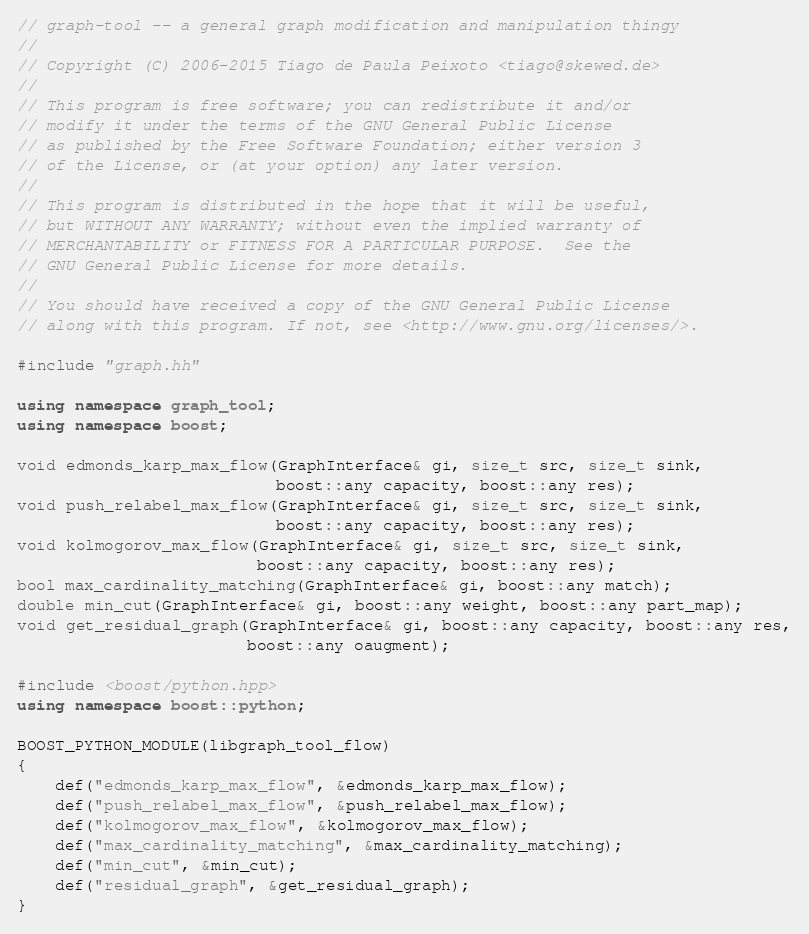<code> <loc_0><loc_0><loc_500><loc_500><_C++_>// graph-tool -- a general graph modification and manipulation thingy
//
// Copyright (C) 2006-2015 Tiago de Paula Peixoto <tiago@skewed.de>
//
// This program is free software; you can redistribute it and/or
// modify it under the terms of the GNU General Public License
// as published by the Free Software Foundation; either version 3
// of the License, or (at your option) any later version.
//
// This program is distributed in the hope that it will be useful,
// but WITHOUT ANY WARRANTY; without even the implied warranty of
// MERCHANTABILITY or FITNESS FOR A PARTICULAR PURPOSE.  See the
// GNU General Public License for more details.
//
// You should have received a copy of the GNU General Public License
// along with this program. If not, see <http://www.gnu.org/licenses/>.

#include "graph.hh"

using namespace graph_tool;
using namespace boost;

void edmonds_karp_max_flow(GraphInterface& gi, size_t src, size_t sink,
                           boost::any capacity, boost::any res);
void push_relabel_max_flow(GraphInterface& gi, size_t src, size_t sink,
                           boost::any capacity, boost::any res);
void kolmogorov_max_flow(GraphInterface& gi, size_t src, size_t sink,
                         boost::any capacity, boost::any res);
bool max_cardinality_matching(GraphInterface& gi, boost::any match);
double min_cut(GraphInterface& gi, boost::any weight, boost::any part_map);
void get_residual_graph(GraphInterface& gi, boost::any capacity, boost::any res,
                        boost::any oaugment);

#include <boost/python.hpp>
using namespace boost::python;

BOOST_PYTHON_MODULE(libgraph_tool_flow)
{
    def("edmonds_karp_max_flow", &edmonds_karp_max_flow);
    def("push_relabel_max_flow", &push_relabel_max_flow);
    def("kolmogorov_max_flow", &kolmogorov_max_flow);
    def("max_cardinality_matching", &max_cardinality_matching);
    def("min_cut", &min_cut);
    def("residual_graph", &get_residual_graph);
}
</code> 